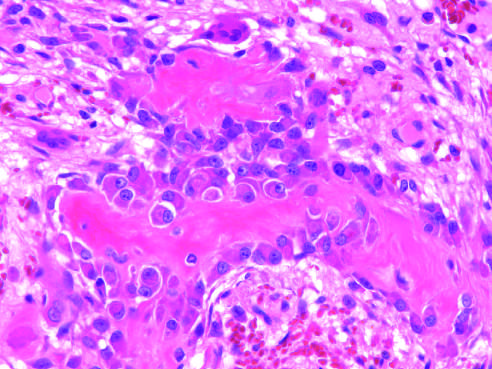what cells represent osteoprogenitor cells?
Answer the question using a single word or phrase. The surrounding spindle cells 